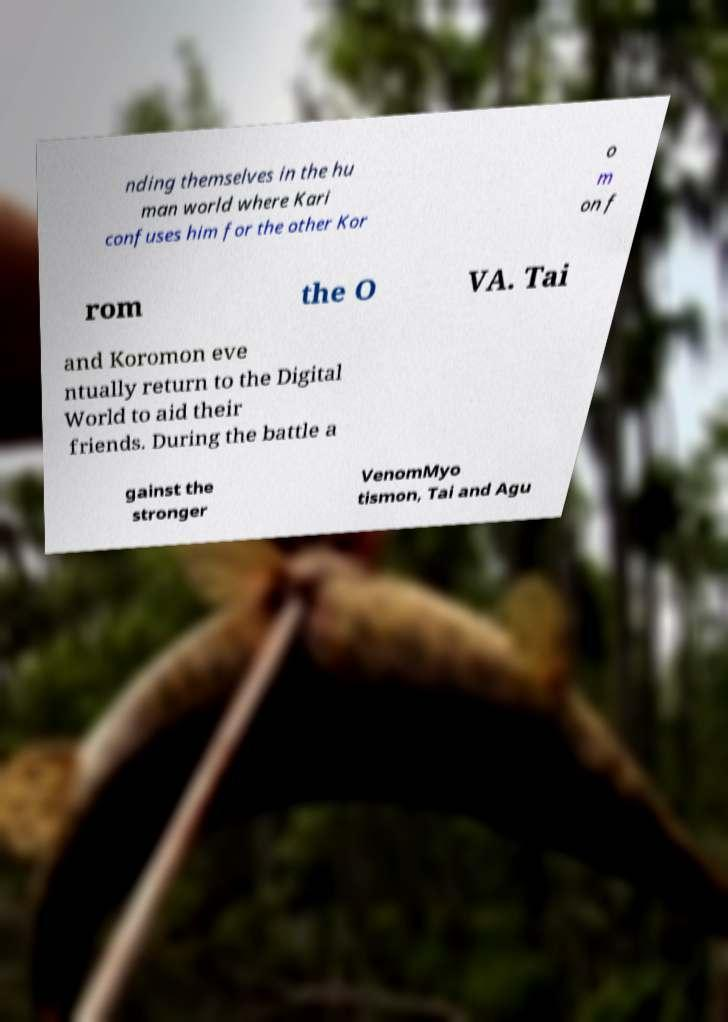Can you read and provide the text displayed in the image?This photo seems to have some interesting text. Can you extract and type it out for me? nding themselves in the hu man world where Kari confuses him for the other Kor o m on f rom the O VA. Tai and Koromon eve ntually return to the Digital World to aid their friends. During the battle a gainst the stronger VenomMyo tismon, Tai and Agu 